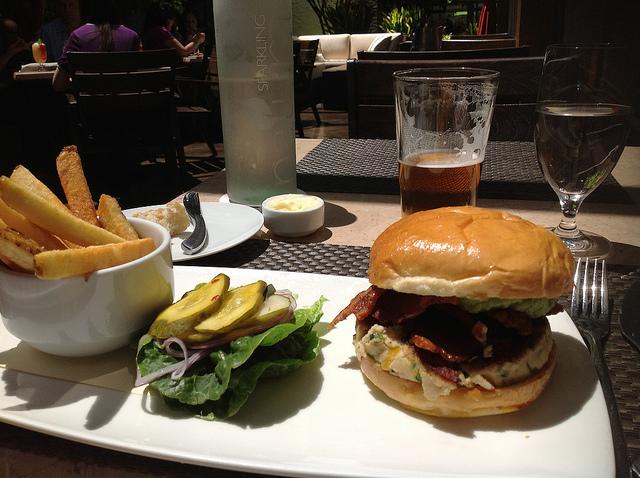Is this in a restaurant?
Give a very brief answer. Yes. Is this a restaurant?
Keep it brief. Yes. How many sandwiches are there?
Be succinct. 1. Does this restaurant target mainly male customers?
Give a very brief answer. No. Has the hamburger been cooked yet?
Answer briefly. Yes. Has the food been tested yet?
Answer briefly. No. 